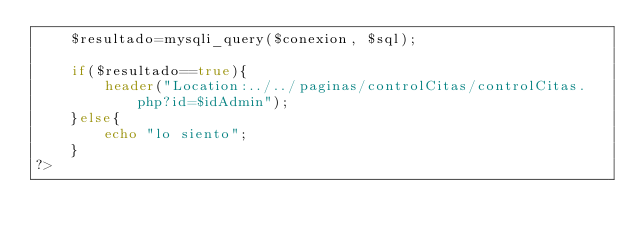Convert code to text. <code><loc_0><loc_0><loc_500><loc_500><_PHP_>    $resultado=mysqli_query($conexion, $sql);

    if($resultado==true){   
        header("Location:../../paginas/controlCitas/controlCitas.php?id=$idAdmin");
    }else{
        echo "lo siento";
    }
?></code> 